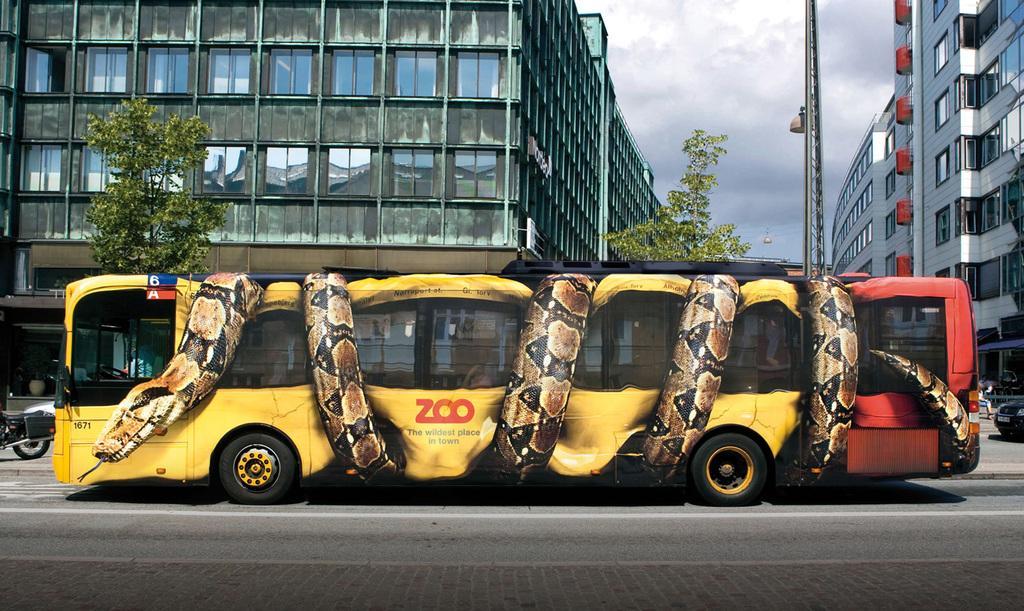Can you describe this image briefly? In this image we can see a vehicle. On the vehicle we can see a painting of a snake and some text. Behind the vehicle we can see few buildings and trees. Beside the vehicle we can see few more vehicles. At the top we can see the sky. 